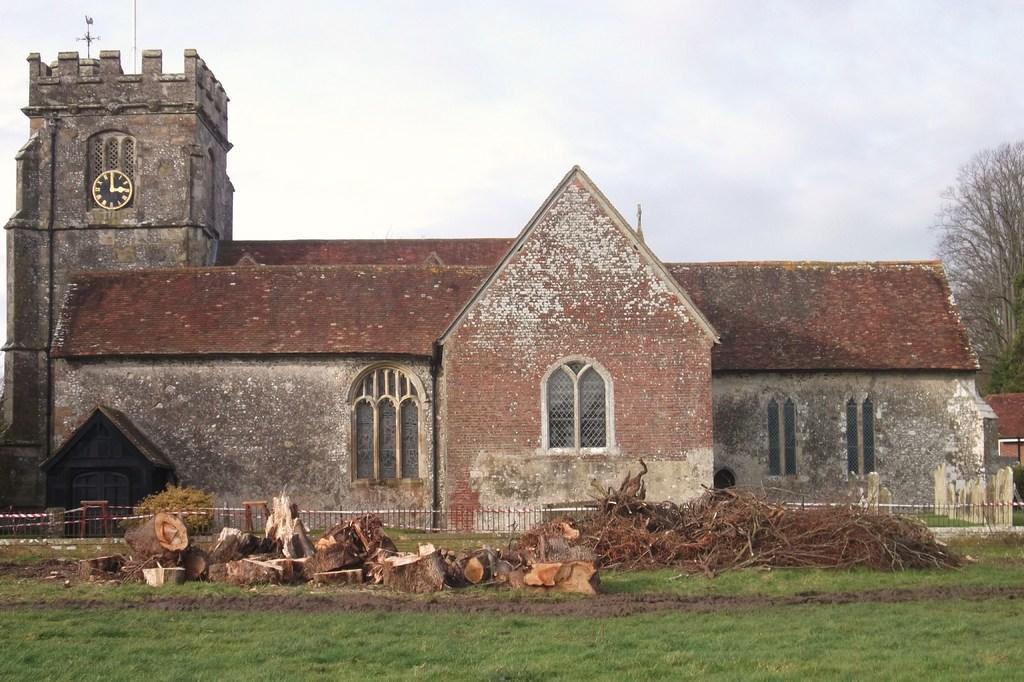Please provide a concise description of this image. In this image, we can see a house with walls and windows. Here there is a clock. Right side of the image, there is a tree. At the bottom, we can see grass, wooden pieces, sticks. Background there is a sky. 